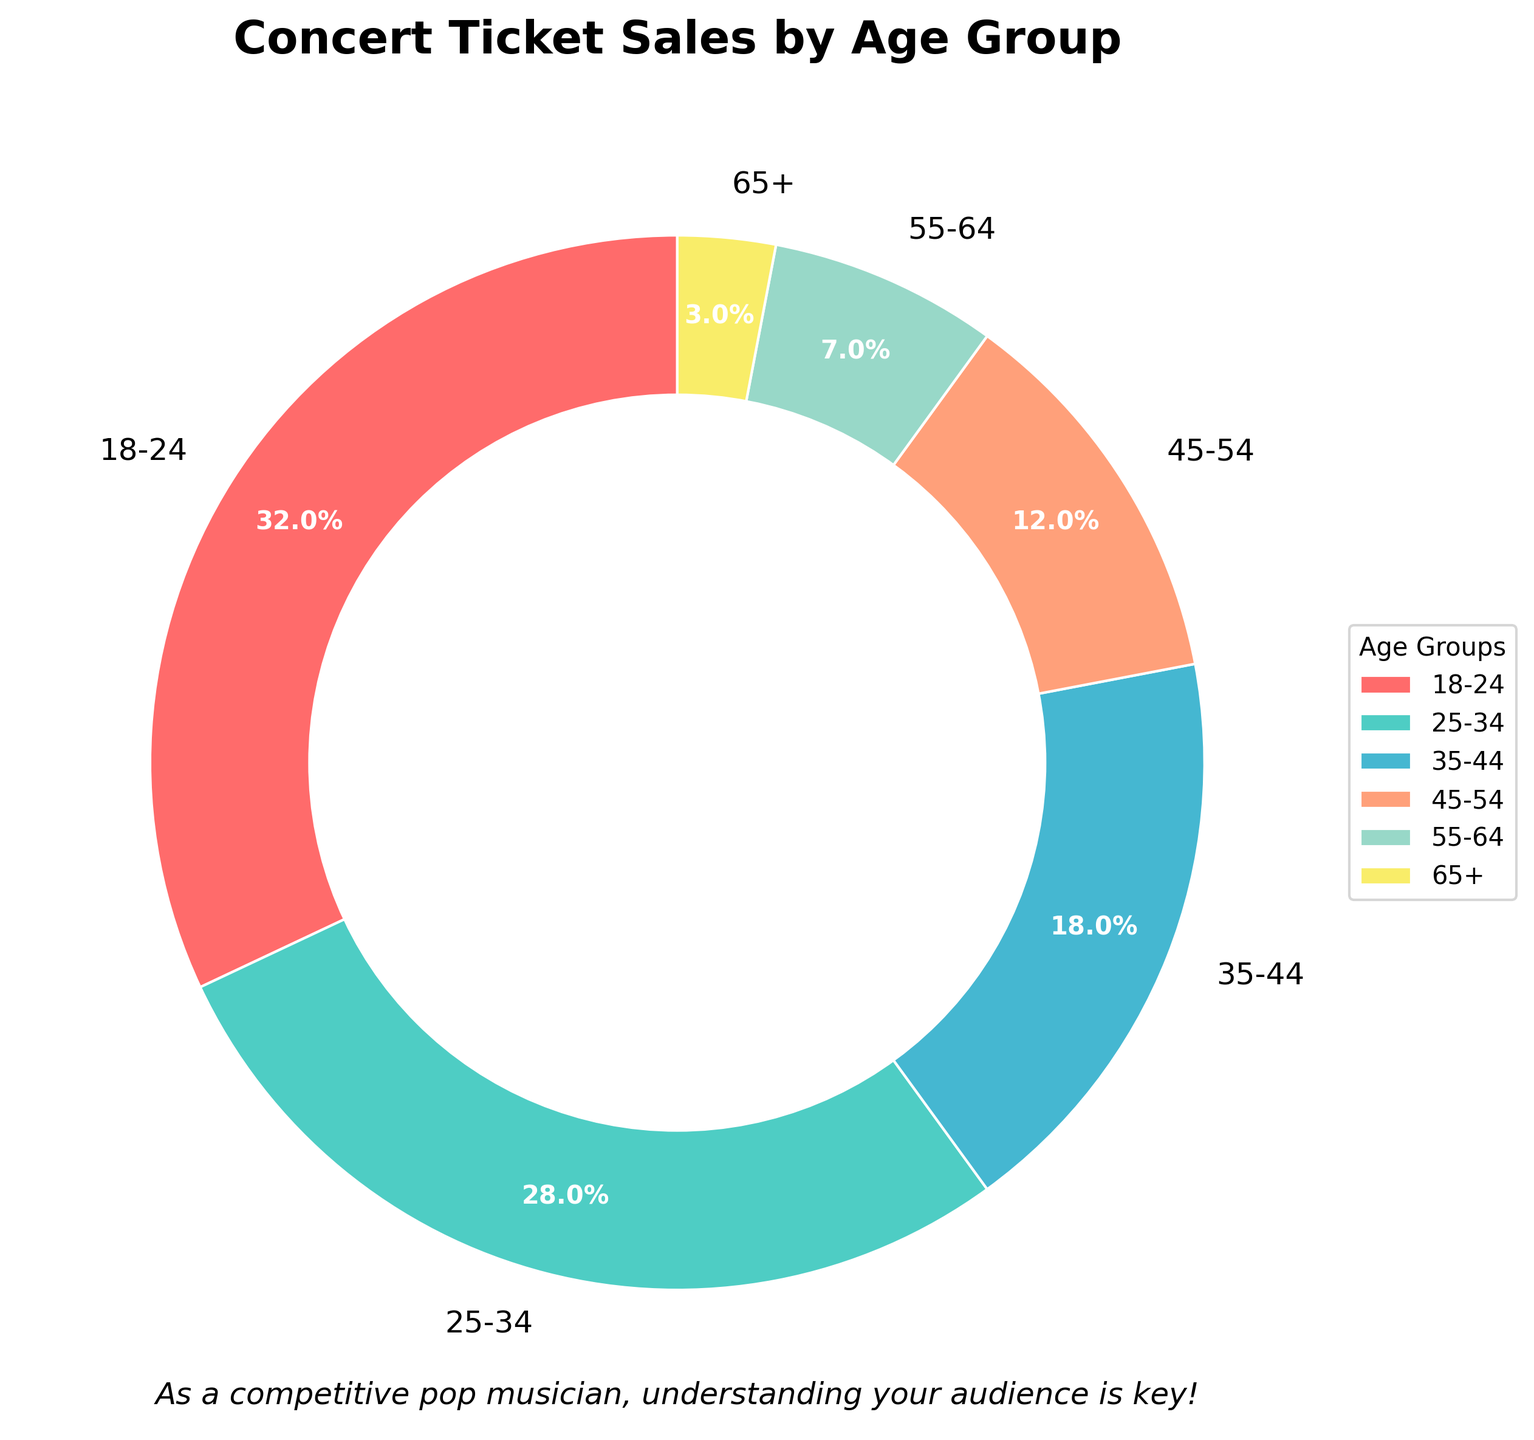Which age group buys the most concert tickets? The pie chart shows the percentage of concert ticket sales by age group. The age group with the largest percentage is 18-24, with 32%.
Answer: 18-24 What is the combined percentage of concert tickets sold to people aged 35-44 and 45-54? To find the total percentage of tickets sold to the 35-44 and 45-54 age groups, add their percentages together: 18% (35-44) + 12% (45-54) = 30%.
Answer: 30% Which age group has the smallest share of concert ticket sales? By observing the pie chart, the age group with the smallest percentage is 65+, which has only 3%.
Answer: 65+ How much larger is the percentage of tickets sold to people aged 18-24 compared to those aged 55-64? Subtract the percentage of the 55-64 age group from the percentage of the 18-24 age group: 32% (18-24) - 7% (55-64) = 25%.
Answer: 25% If you add up the percentages of the two youngest age groups (18-24 and 25-34), what percentage of total ticket sales do they make up? To calculate the combined percentage of the two youngest age groups, add 32% (18-24) and 28% (25-34): 32% + 28% = 60%.
Answer: 60% What is the difference in concert ticket sales percentage between the 25-34 and 45-54 age groups? Subtract the percentage of the 45-54 age group from the percentage of the 25-34 age group: 28% (25-34) - 12% (45-54) = 16%.
Answer: 16% Which age groups each have more than one-quarter of the total concert ticket sales? The pie chart shows that the age groups with more than 25% of total sales are 18-24 (32%) and 25-34 (28%).
Answer: 18-24, 25-34 If the percentage difference between each successive age group were calculated, which pair of consecutive age groups would have the smallest difference? Calculate the differences between each consecutive pair: 32% - 28% = 4% (18-24 vs 25-34); 28% - 18% = 10% (25-34 vs 35-44); 18% - 12% = 6% (35-44 vs 45-54); 12% - 7% = 5% (45-54 vs 55-64); 7% - 3% = 4% (55-64 vs 65+). The smallest difference is 4%, which occurs between 18-24 and 25-34, and between 55-64 and 65+.
Answer: 18-24 vs 25-34, and 55-64 vs 65+ What is the total percentage of concert tickets sold to people aged 35 and older? To find the total percentage of tickets sold to people aged 35 and older, add the percentages of the 35-44, 45-54, 55-64, and 65+ groups: 18% + 12% + 7% + 3% = 40%.
Answer: 40% What is the percentage difference between the age group with the highest ticket sales and the age group with the lowest ticket sales? Subtract the percentage of the 65+ age group from the percentage of the 18-24 age group: 32% (18-24) - 3% (65+) = 29%.
Answer: 29% 